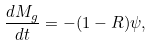Convert formula to latex. <formula><loc_0><loc_0><loc_500><loc_500>\frac { d M _ { g } } { d t } = - ( 1 - R ) \psi ,</formula> 